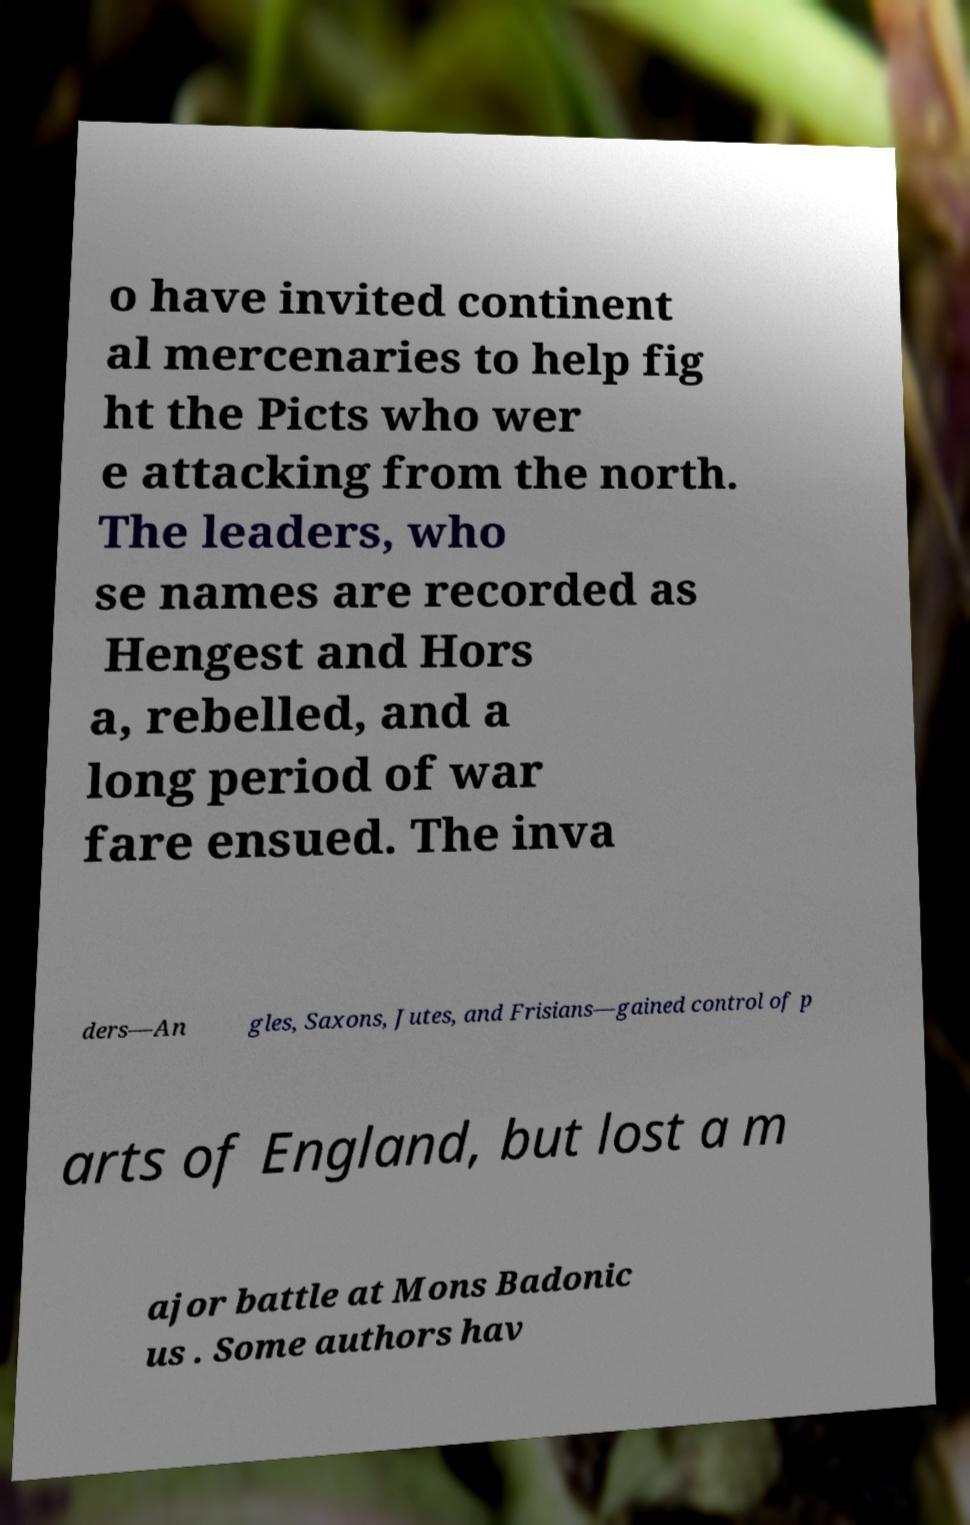There's text embedded in this image that I need extracted. Can you transcribe it verbatim? o have invited continent al mercenaries to help fig ht the Picts who wer e attacking from the north. The leaders, who se names are recorded as Hengest and Hors a, rebelled, and a long period of war fare ensued. The inva ders—An gles, Saxons, Jutes, and Frisians—gained control of p arts of England, but lost a m ajor battle at Mons Badonic us . Some authors hav 